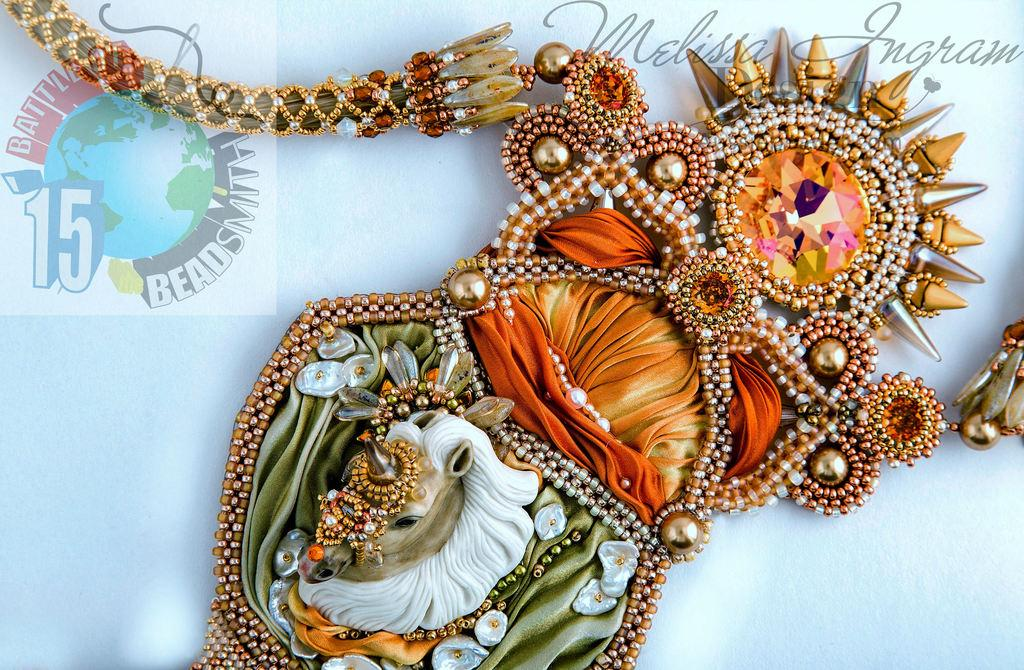What type of objects can be seen in the image? There are stones, beads, pearls, and a chain in the image. What are the colors of the objects in the image? The stones, beads, pearls, and chain are in various colors, including orange, green, and yellow. What is the background color of the image? The background of the image is blue. Is there any text or symbol in the image? Yes, there is a watermark at the top of the image. Can you see any kettles in the image? No, there are no kettles present in the image. Are there any legs visible in the image? No, there are no legs visible in the image. 